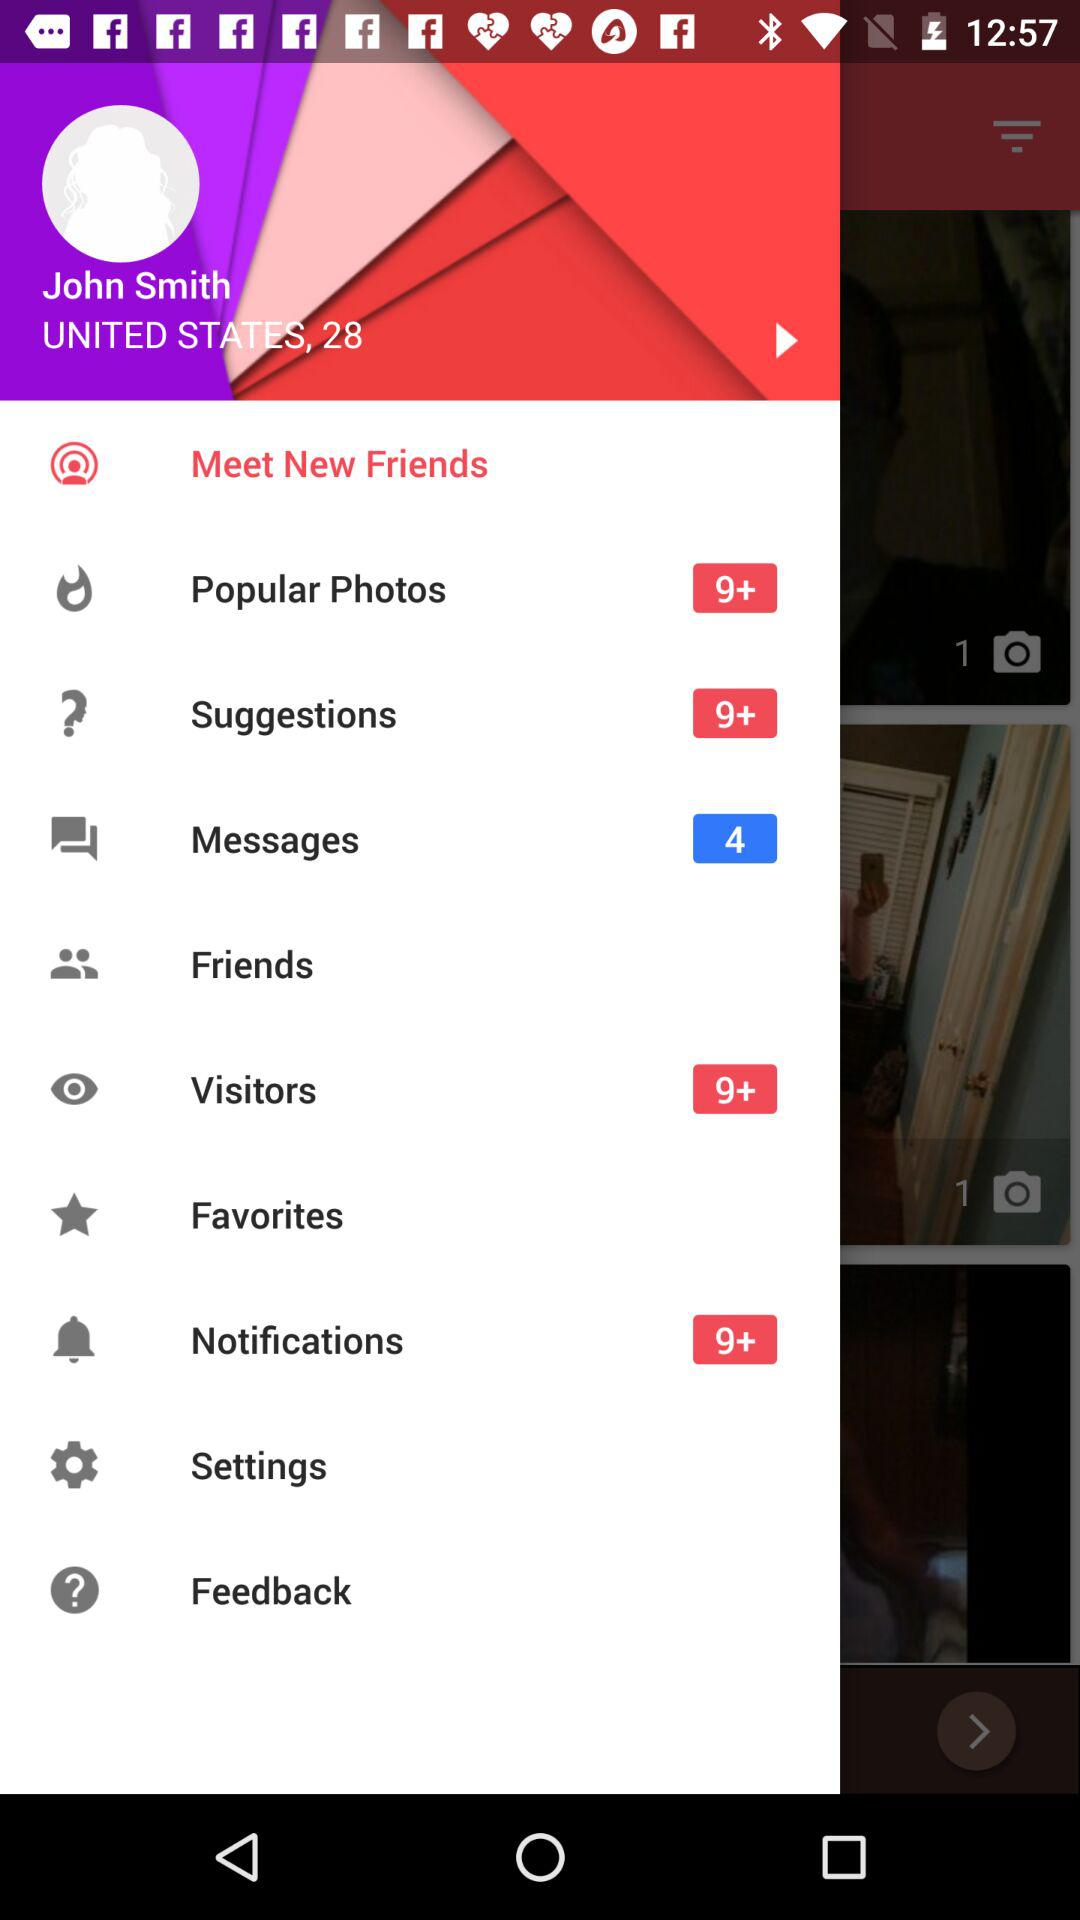To what location does John Smith belong? John Smith belongs to the United States. 